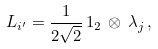Convert formula to latex. <formula><loc_0><loc_0><loc_500><loc_500>L _ { i ^ { \prime } } = \frac { 1 } { 2 \sqrt { 2 } } \, 1 _ { 2 } \, \otimes \, \lambda _ { j } \, ,</formula> 